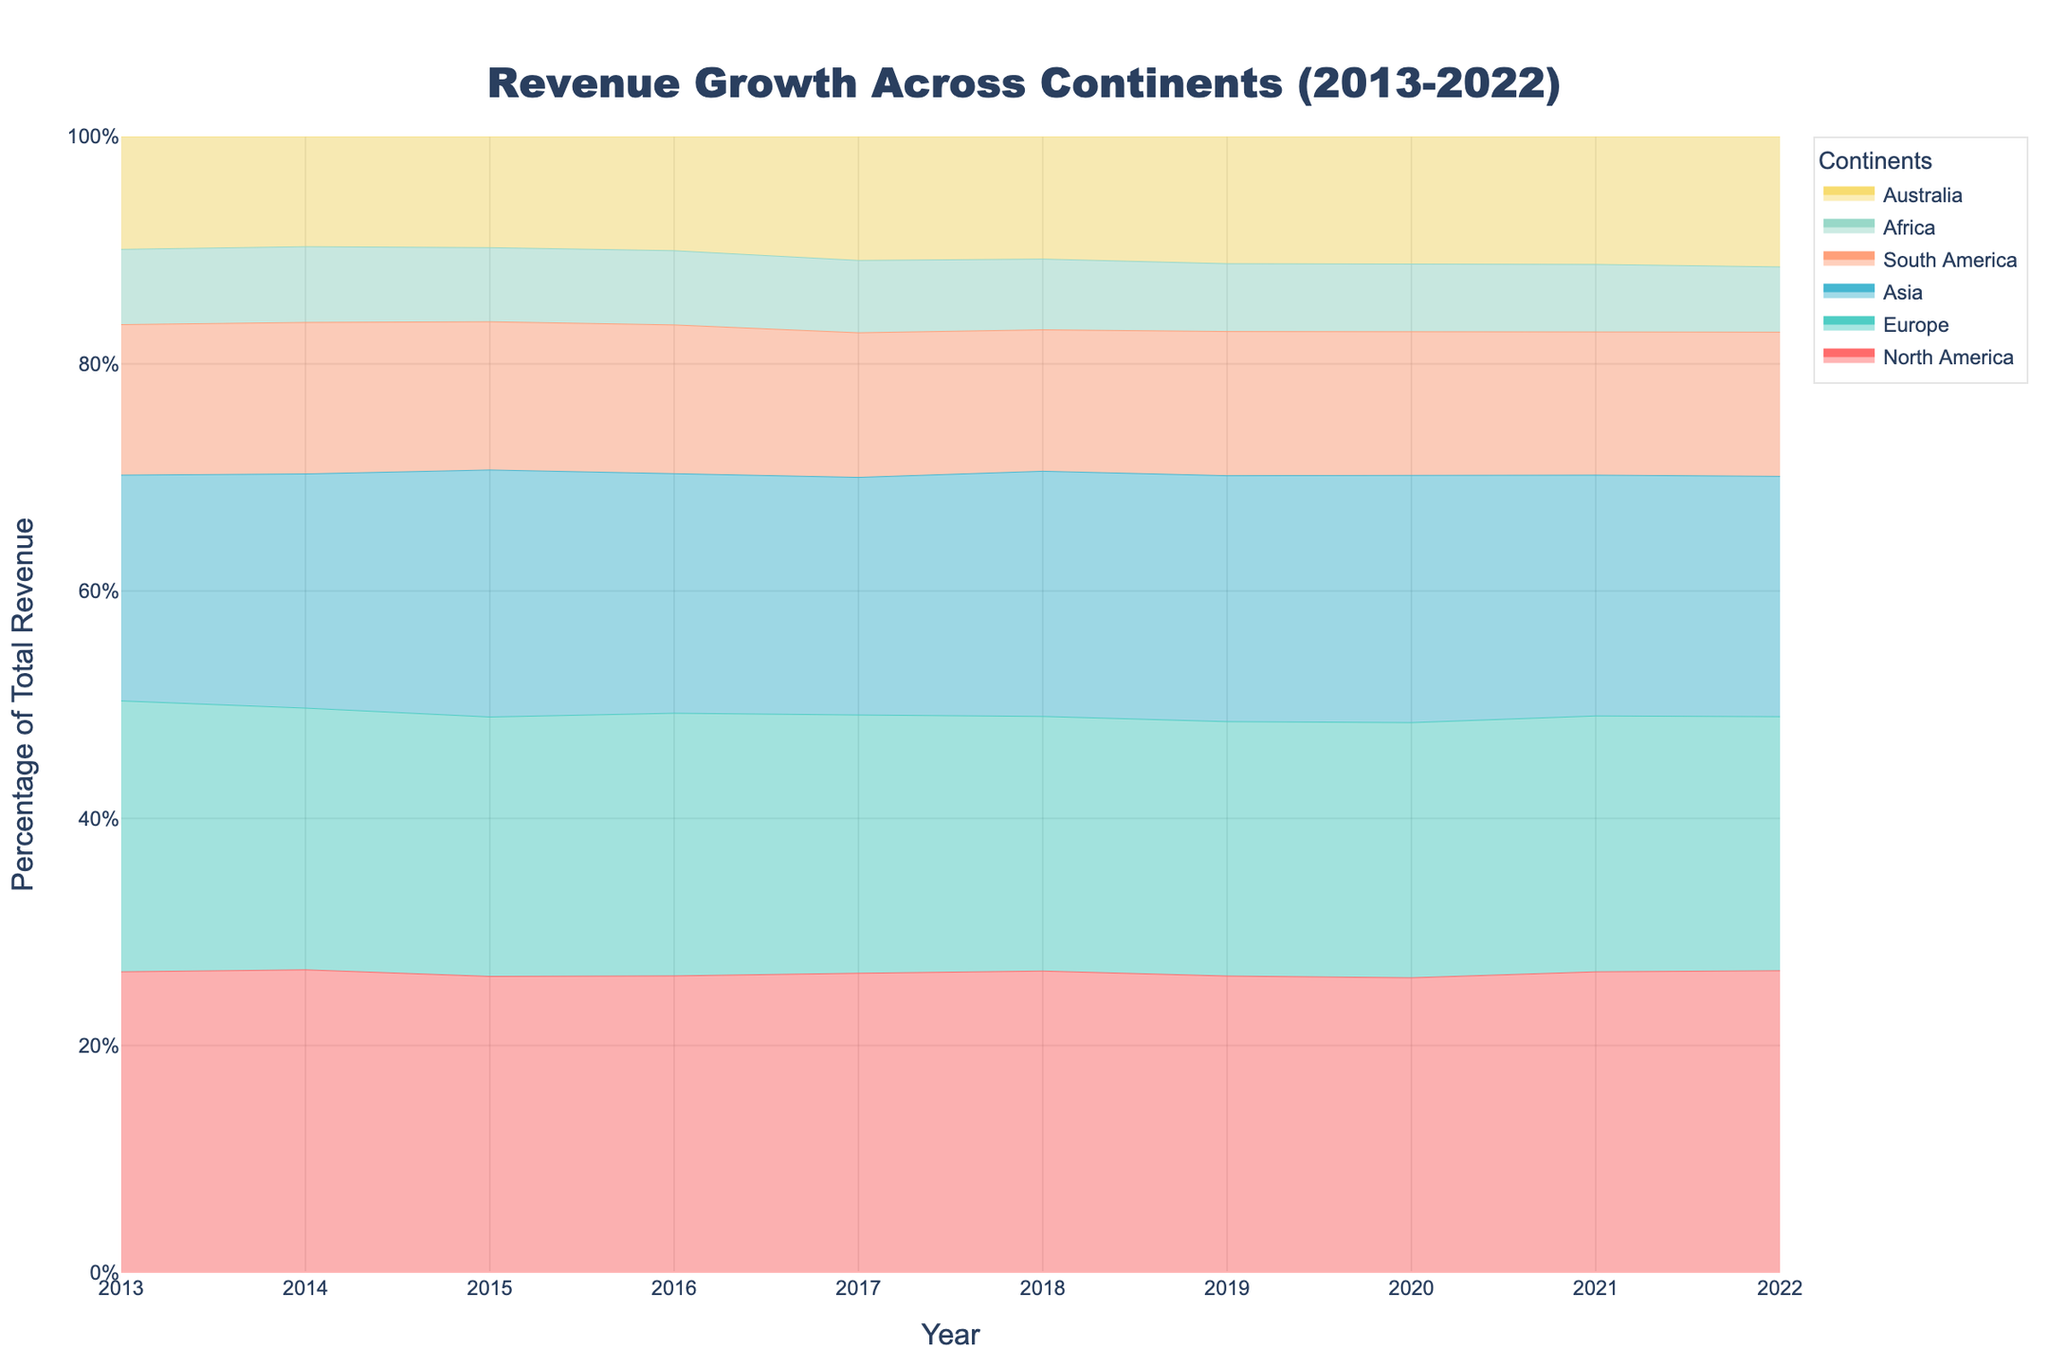What's the title of the figure? The title is displayed prominently at the top of the figure. It gives an overview of what the figure represents.
Answer: Revenue Growth Across Continents (2013-2022) Which continent had the highest revenue in 2022? The area chart shows the cumulative revenue growth across different continents. The continent with the highest top boundary in 2022 indicates the highest revenue. North America has the highest revenue.
Answer: North America How did the revenue for Africa change from 2013 to 2022? By observing the height of the colored area corresponding to Africa, we can see that it grows steadily from 2013 to 2022. In 2013, Africa had the smallest area, and by 2022, it still remains the smallest but has increased.
Answer: It increased What is the trend of revenue growth for Europe from 2013 to 2022? The area representing Europe increases from 2013 to 2022, indicating a steady rise in revenue each year.
Answer: Steady increase Which two continents showed the most significant revenue growth between 2016 and 2019? By comparing the change in area size between these years for each continent, North America and Europe show the most significant increase.
Answer: North America and Europe In which year did Asia's revenue surpass 200? By looking at the stacked areas and finding the point where the cumulative revenue for Asia alone passes 200, we find it occurs in 2015.
Answer: 2015 Compare the revenue growth of South America and Australia in 2022. Which one is greater and by approximately how much? By checking the areas representing South America and Australia, we can see that South America is larger in 2022. The difference is the height difference between the cumulative areas. South America (210) and Australia (190); so approximately by 20.
Answer: South America by approximately 20 What is the visual color used to represent the revenue for Australia? The color used for Australia can be identified visually in the legend and chart. It is shown in a yellow shade.
Answer: Yellow Did any continent see a decrease in revenue at any point from 2013 to 2022? All areas representing the continents increase steadily without any dips downward, indicating constant growth.
Answer: No Which year saw the most significant jump in total revenue across all continents combined? By observing the gap between cumulative revenue lines year by year, 2022 shows the most noticeable increase in height, indicating the significant jump.
Answer: 2022 